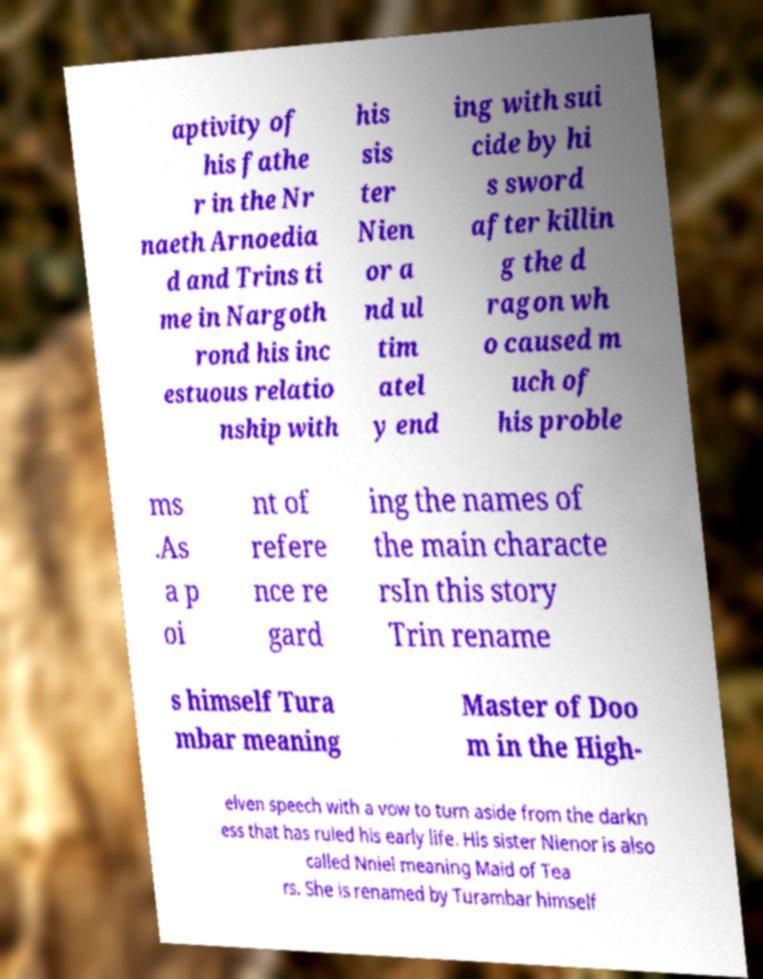Could you assist in decoding the text presented in this image and type it out clearly? aptivity of his fathe r in the Nr naeth Arnoedia d and Trins ti me in Nargoth rond his inc estuous relatio nship with his sis ter Nien or a nd ul tim atel y end ing with sui cide by hi s sword after killin g the d ragon wh o caused m uch of his proble ms .As a p oi nt of refere nce re gard ing the names of the main characte rsIn this story Trin rename s himself Tura mbar meaning Master of Doo m in the High- elven speech with a vow to turn aside from the darkn ess that has ruled his early life. His sister Nienor is also called Nniel meaning Maid of Tea rs. She is renamed by Turambar himself 